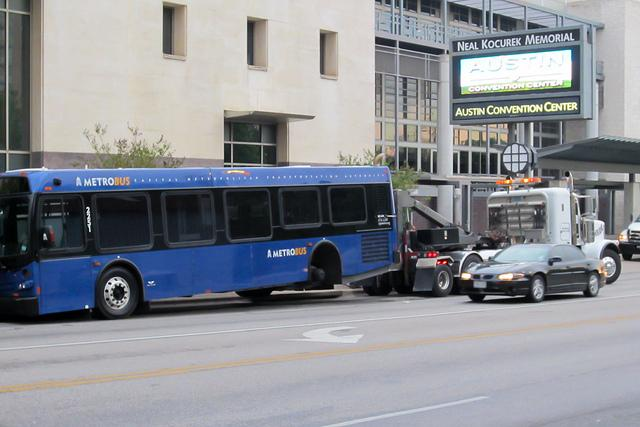In which state is this bus being towed? Please explain your reasoning. texas. The state is texas. 